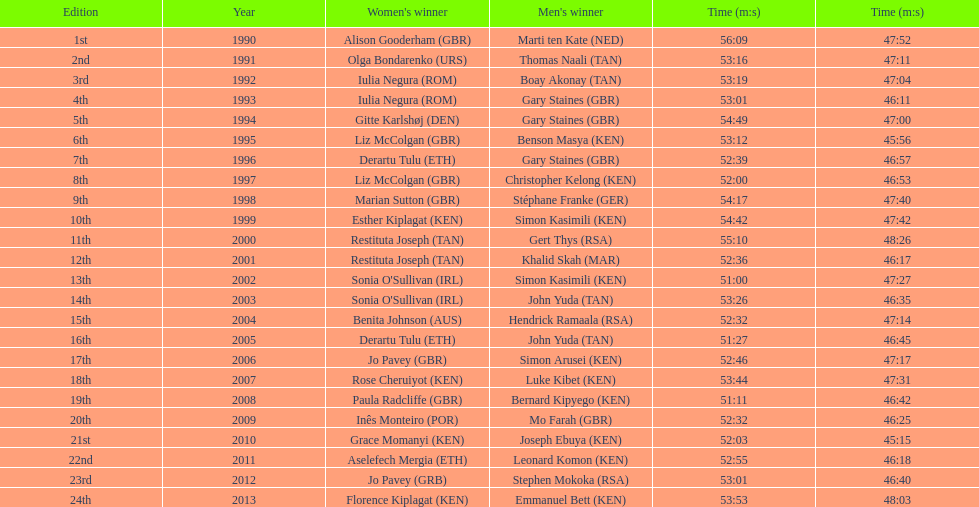Which runners are from kenya? (ken) Benson Masya (KEN), Christopher Kelong (KEN), Simon Kasimili (KEN), Simon Kasimili (KEN), Simon Arusei (KEN), Luke Kibet (KEN), Bernard Kipyego (KEN), Joseph Ebuya (KEN), Leonard Komon (KEN), Emmanuel Bett (KEN). Of these, which times are under 46 minutes? Benson Masya (KEN), Joseph Ebuya (KEN). Which of these runners had the faster time? Joseph Ebuya (KEN). 